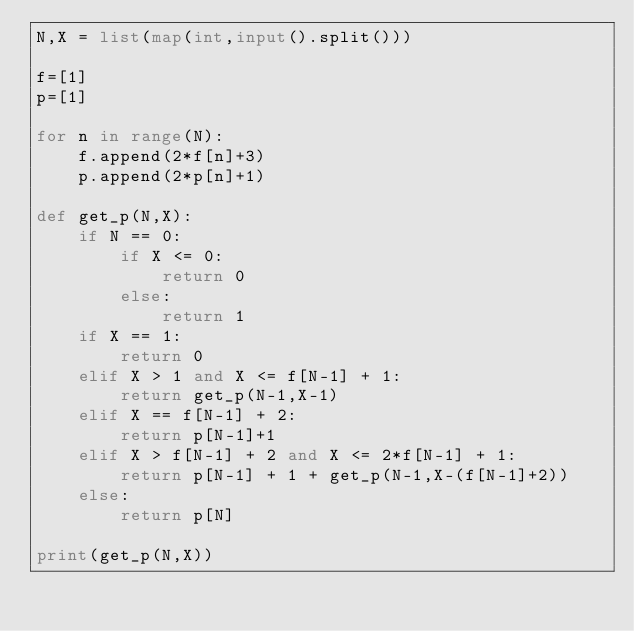<code> <loc_0><loc_0><loc_500><loc_500><_Python_>N,X = list(map(int,input().split()))

f=[1]
p=[1]

for n in range(N):
    f.append(2*f[n]+3)
    p.append(2*p[n]+1)

def get_p(N,X):
    if N == 0:
        if X <= 0:
            return 0
        else:
            return 1
    if X == 1:
        return 0
    elif X > 1 and X <= f[N-1] + 1:
        return get_p(N-1,X-1)
    elif X == f[N-1] + 2:
        return p[N-1]+1
    elif X > f[N-1] + 2 and X <= 2*f[N-1] + 1: 
        return p[N-1] + 1 + get_p(N-1,X-(f[N-1]+2))
    else:
        return p[N]
    
print(get_p(N,X))</code> 